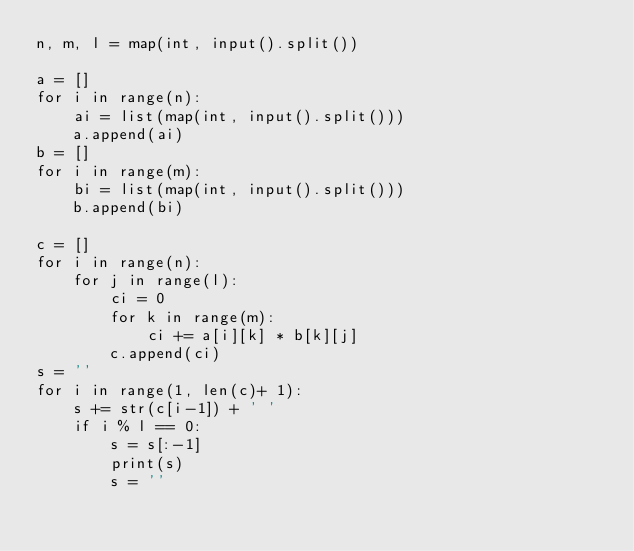Convert code to text. <code><loc_0><loc_0><loc_500><loc_500><_Python_>n, m, l = map(int, input().split())

a = []
for i in range(n):
    ai = list(map(int, input().split()))
    a.append(ai)
b = []
for i in range(m):
    bi = list(map(int, input().split()))
    b.append(bi)

c = []
for i in range(n):
    for j in range(l):
        ci = 0
        for k in range(m):
            ci += a[i][k] * b[k][j]
        c.append(ci)
s = ''
for i in range(1, len(c)+ 1):
    s += str(c[i-1]) + ' '
    if i % l == 0:
        s = s[:-1]
        print(s)
        s = ''
   
</code> 